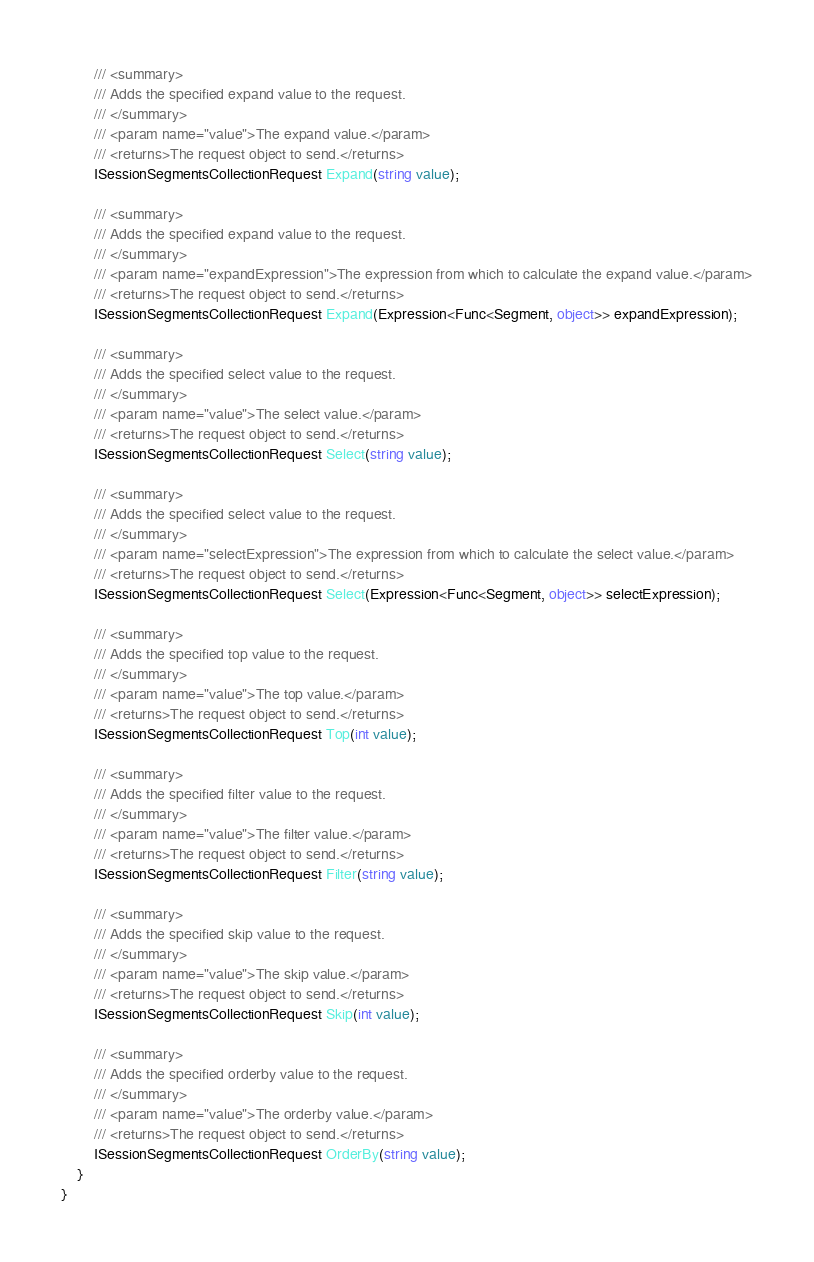<code> <loc_0><loc_0><loc_500><loc_500><_C#_>        /// <summary>
        /// Adds the specified expand value to the request.
        /// </summary>
        /// <param name="value">The expand value.</param>
        /// <returns>The request object to send.</returns>
        ISessionSegmentsCollectionRequest Expand(string value);

        /// <summary>
        /// Adds the specified expand value to the request.
        /// </summary>
        /// <param name="expandExpression">The expression from which to calculate the expand value.</param>
        /// <returns>The request object to send.</returns>
        ISessionSegmentsCollectionRequest Expand(Expression<Func<Segment, object>> expandExpression);

        /// <summary>
        /// Adds the specified select value to the request.
        /// </summary>
        /// <param name="value">The select value.</param>
        /// <returns>The request object to send.</returns>
        ISessionSegmentsCollectionRequest Select(string value);

        /// <summary>
        /// Adds the specified select value to the request.
        /// </summary>
        /// <param name="selectExpression">The expression from which to calculate the select value.</param>
        /// <returns>The request object to send.</returns>
        ISessionSegmentsCollectionRequest Select(Expression<Func<Segment, object>> selectExpression);

        /// <summary>
        /// Adds the specified top value to the request.
        /// </summary>
        /// <param name="value">The top value.</param>
        /// <returns>The request object to send.</returns>
        ISessionSegmentsCollectionRequest Top(int value);

        /// <summary>
        /// Adds the specified filter value to the request.
        /// </summary>
        /// <param name="value">The filter value.</param>
        /// <returns>The request object to send.</returns>
        ISessionSegmentsCollectionRequest Filter(string value);

        /// <summary>
        /// Adds the specified skip value to the request.
        /// </summary>
        /// <param name="value">The skip value.</param>
        /// <returns>The request object to send.</returns>
        ISessionSegmentsCollectionRequest Skip(int value);

        /// <summary>
        /// Adds the specified orderby value to the request.
        /// </summary>
        /// <param name="value">The orderby value.</param>
        /// <returns>The request object to send.</returns>
        ISessionSegmentsCollectionRequest OrderBy(string value);
    }
}
</code> 